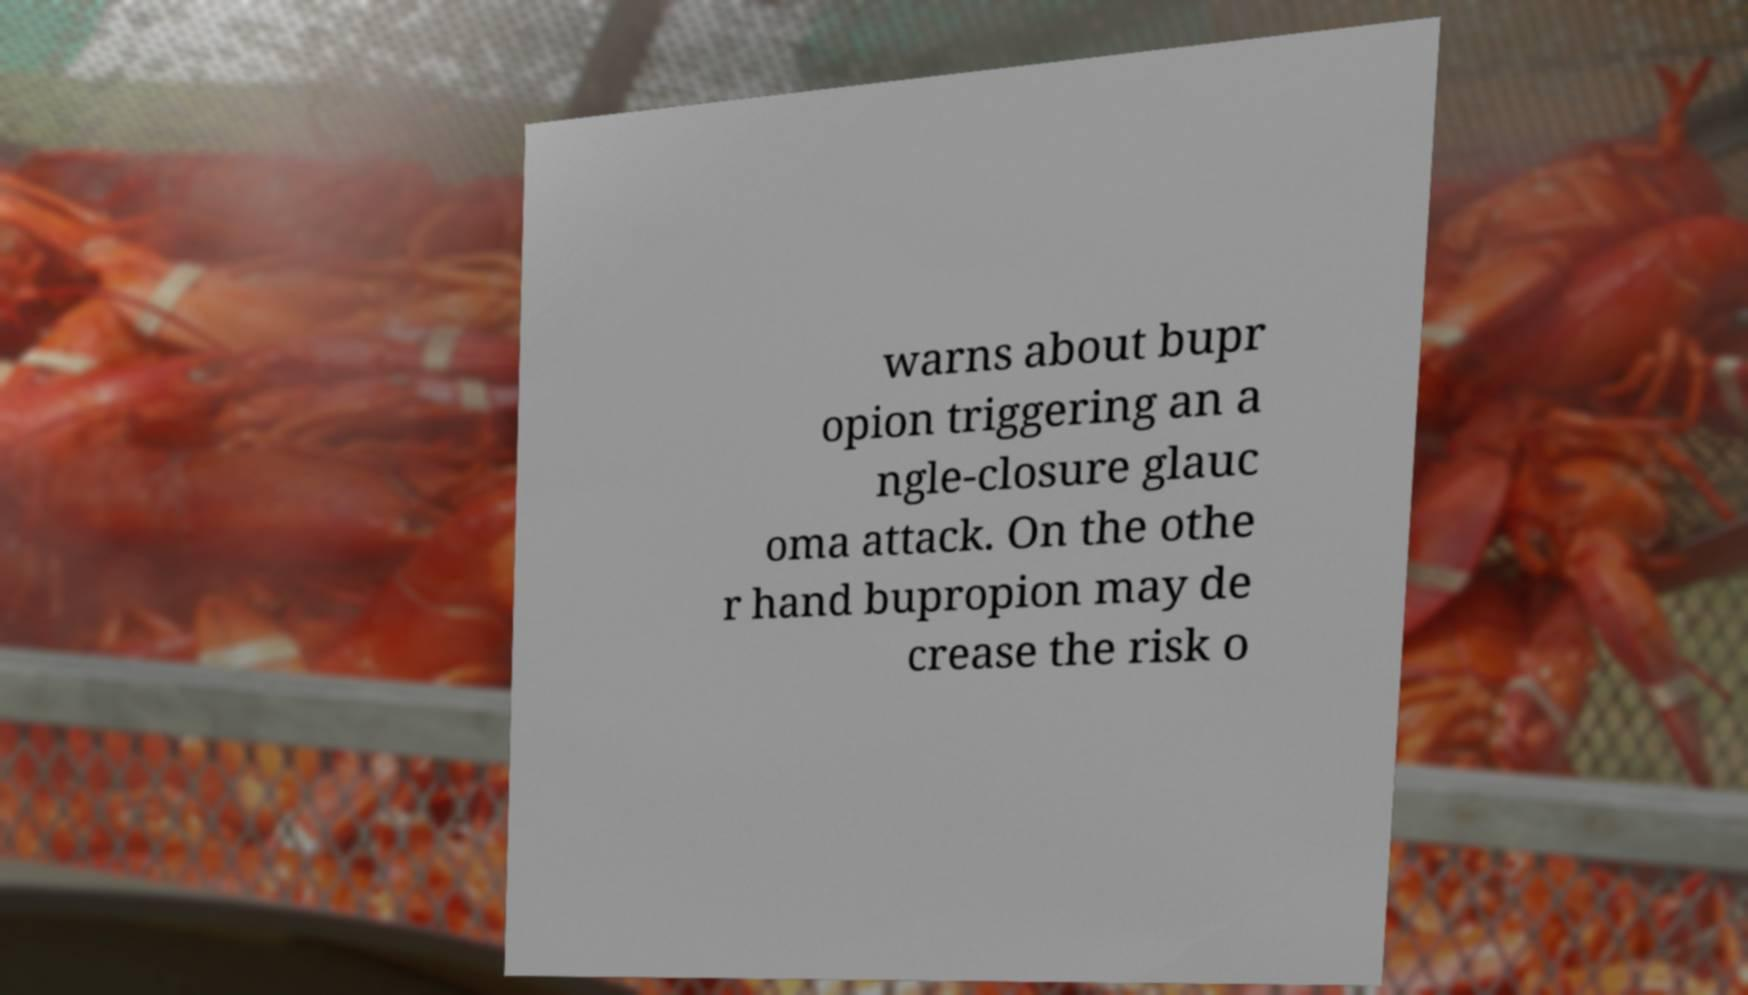Can you read and provide the text displayed in the image?This photo seems to have some interesting text. Can you extract and type it out for me? warns about bupr opion triggering an a ngle-closure glauc oma attack. On the othe r hand bupropion may de crease the risk o 